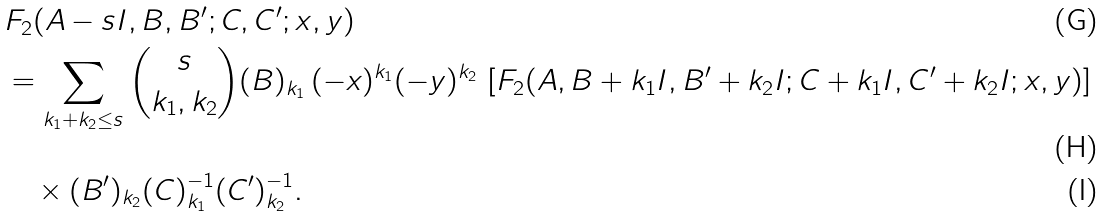Convert formula to latex. <formula><loc_0><loc_0><loc_500><loc_500>& F _ { 2 } ( A - s I , B , B ^ { \prime } ; C , C ^ { \prime } ; x , y ) \\ & = \sum _ { k _ { 1 } + k _ { 2 } \leq s } { s \choose k _ { 1 } , k _ { 2 } } ( B ) _ { k _ { 1 } } \, ( - x ) ^ { k _ { 1 } } ( - y ) ^ { k _ { 2 } } \, \left [ { F _ { 2 } } ( A , B + k _ { 1 } I , B ^ { \prime } + k _ { 2 } I ; C + k _ { 1 } I , C ^ { \prime } + k _ { 2 } I ; x , y ) \right ] \\ & \quad \times ( B ^ { \prime } ) _ { k _ { 2 } } { ( C ) ^ { - 1 } _ { k _ { 1 } } ( C ^ { \prime } ) ^ { - 1 } _ { k _ { 2 } } } .</formula> 